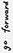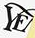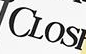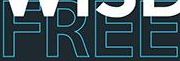What text is displayed in these images sequentially, separated by a semicolon? #; YE; CLOS; FREE 